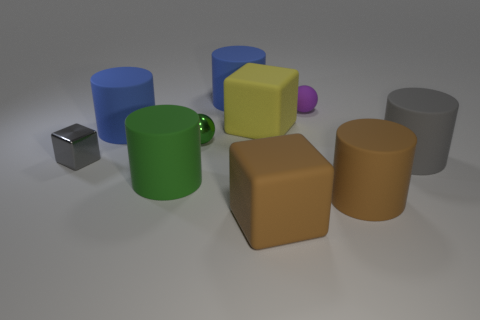Subtract all rubber cubes. How many cubes are left? 1 Subtract all green cylinders. How many cylinders are left? 4 Subtract 0 red cylinders. How many objects are left? 10 Subtract all blocks. How many objects are left? 7 Subtract 1 blocks. How many blocks are left? 2 Subtract all cyan cylinders. Subtract all yellow spheres. How many cylinders are left? 5 Subtract all green cubes. How many brown cylinders are left? 1 Subtract all red matte cubes. Subtract all gray matte cylinders. How many objects are left? 9 Add 4 matte cubes. How many matte cubes are left? 6 Add 1 metallic cylinders. How many metallic cylinders exist? 1 